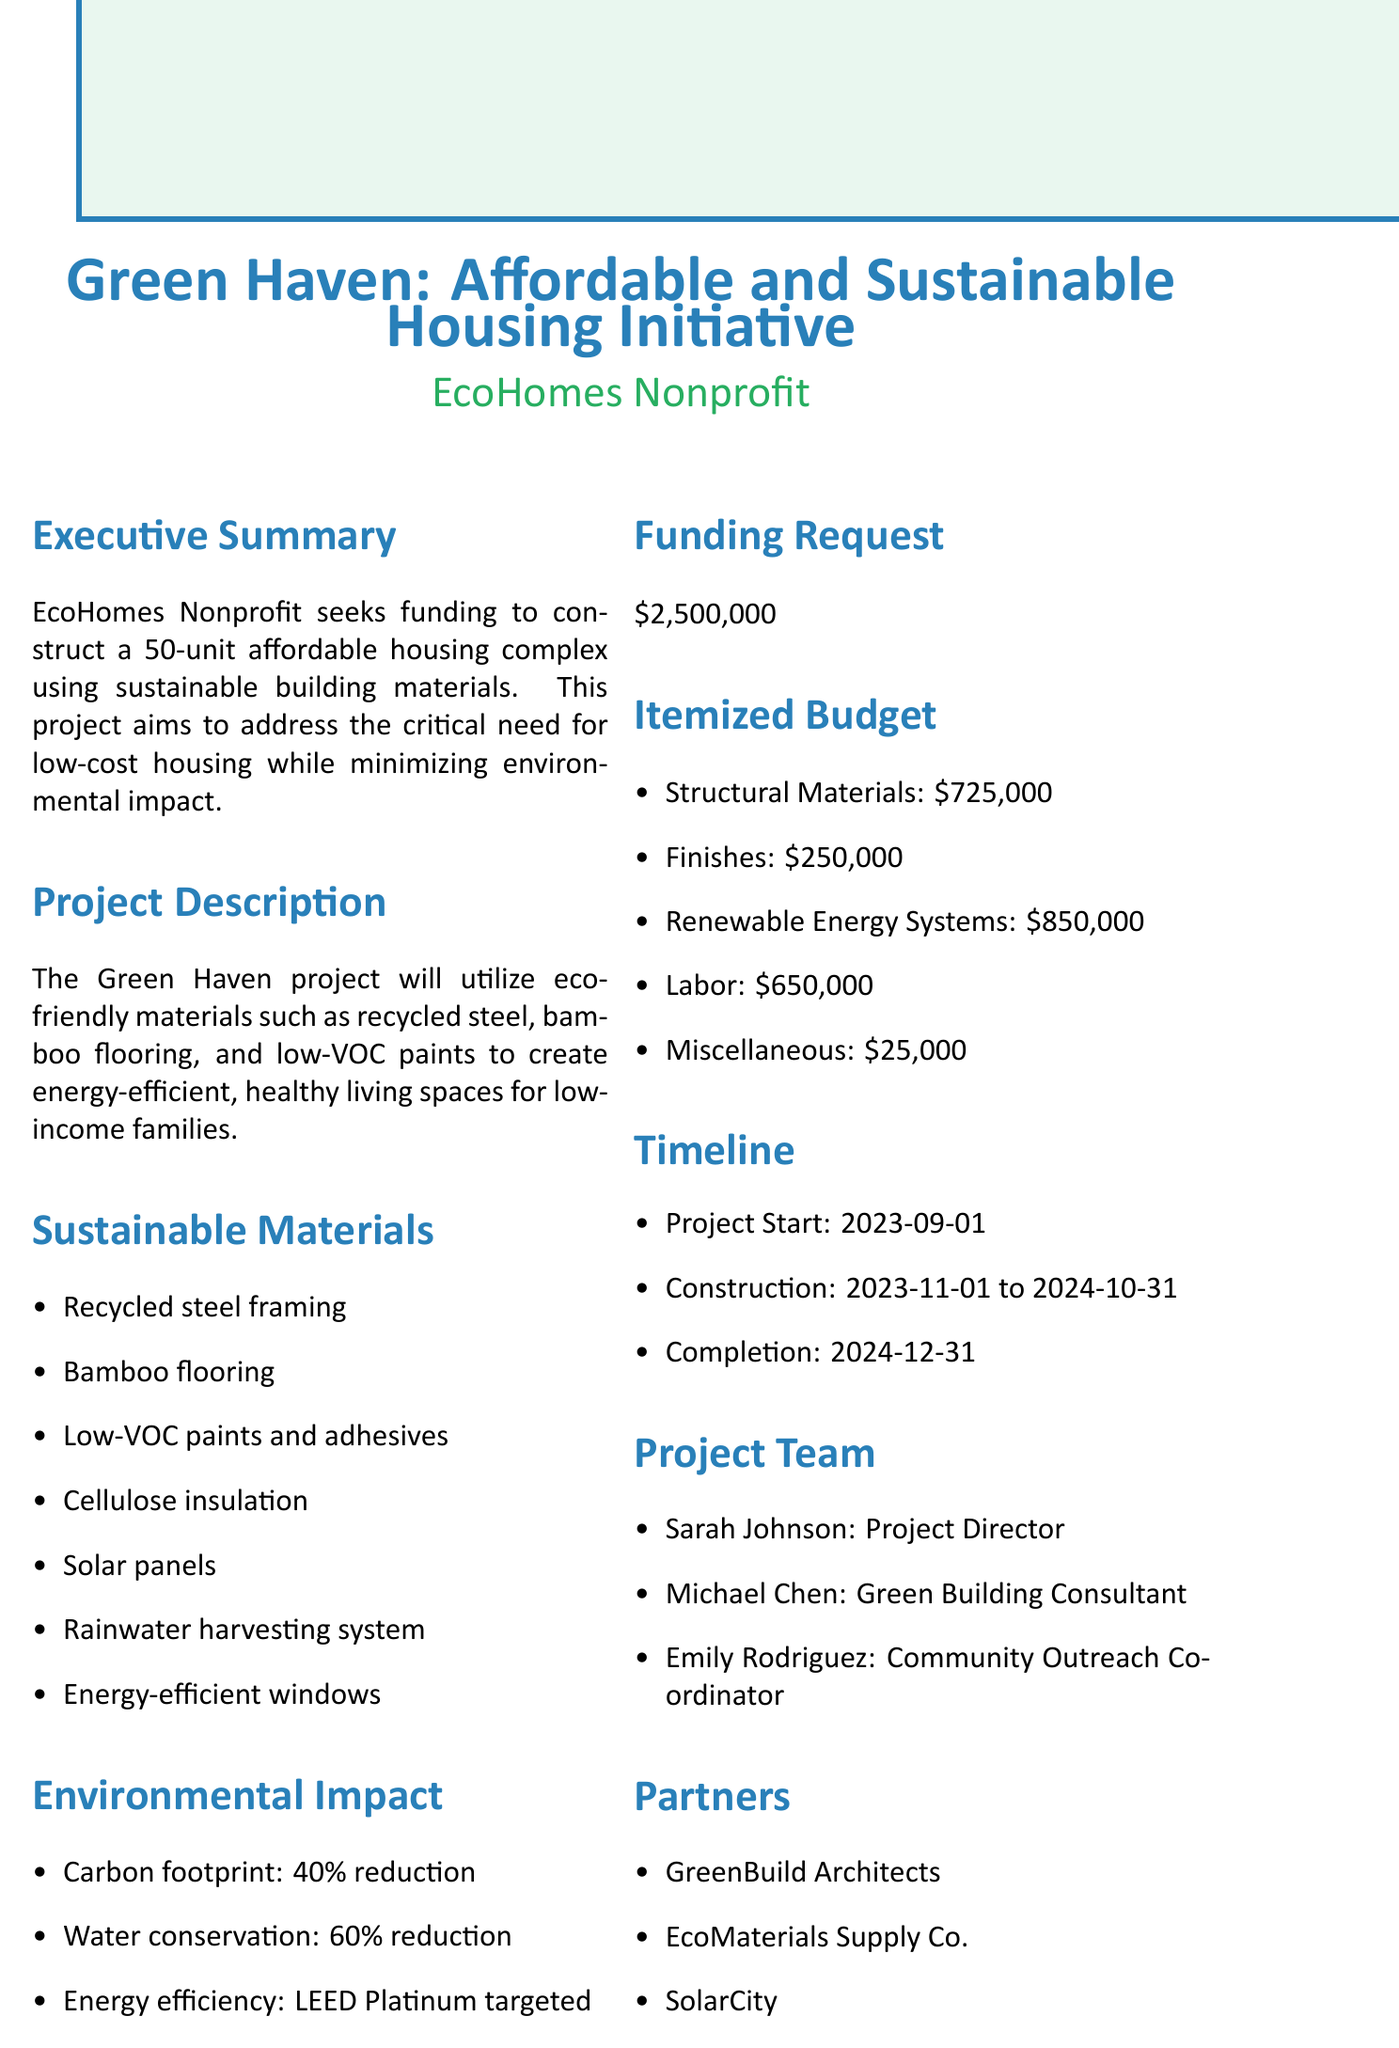What is the project title? The project title is stated at the beginning of the document.
Answer: Green Haven: Affordable and Sustainable Housing Initiative What is the total funding request? The funding request is clearly stated in the document.
Answer: $2,500,000 How many units will the housing complex have? The number of units is mentioned in the project description.
Answer: 50 What is the targeted energy efficiency certification? The document specifies the energy efficiency certification aimed for the project.
Answer: LEED Platinum What is the cost of bamboo flooring? The cost breakdown for each item is provided in the itemized budget section.
Answer: 175000 What is the role of Sarah Johnson in the project? Sarah Johnson's role is listed in the project team section.
Answer: Project Director Which organization is responsible for solar panel installation? The partnering organization for solar panel installation is mentioned in the partners section.
Answer: SolarCity How much is allocated for permits and fees? The itemized budget provides specific costs for each category, including miscellaneous costs.
Answer: 25000 What is the projected completion date of the project? The completion date is given in the timeline section.
Answer: 2024-12-31 